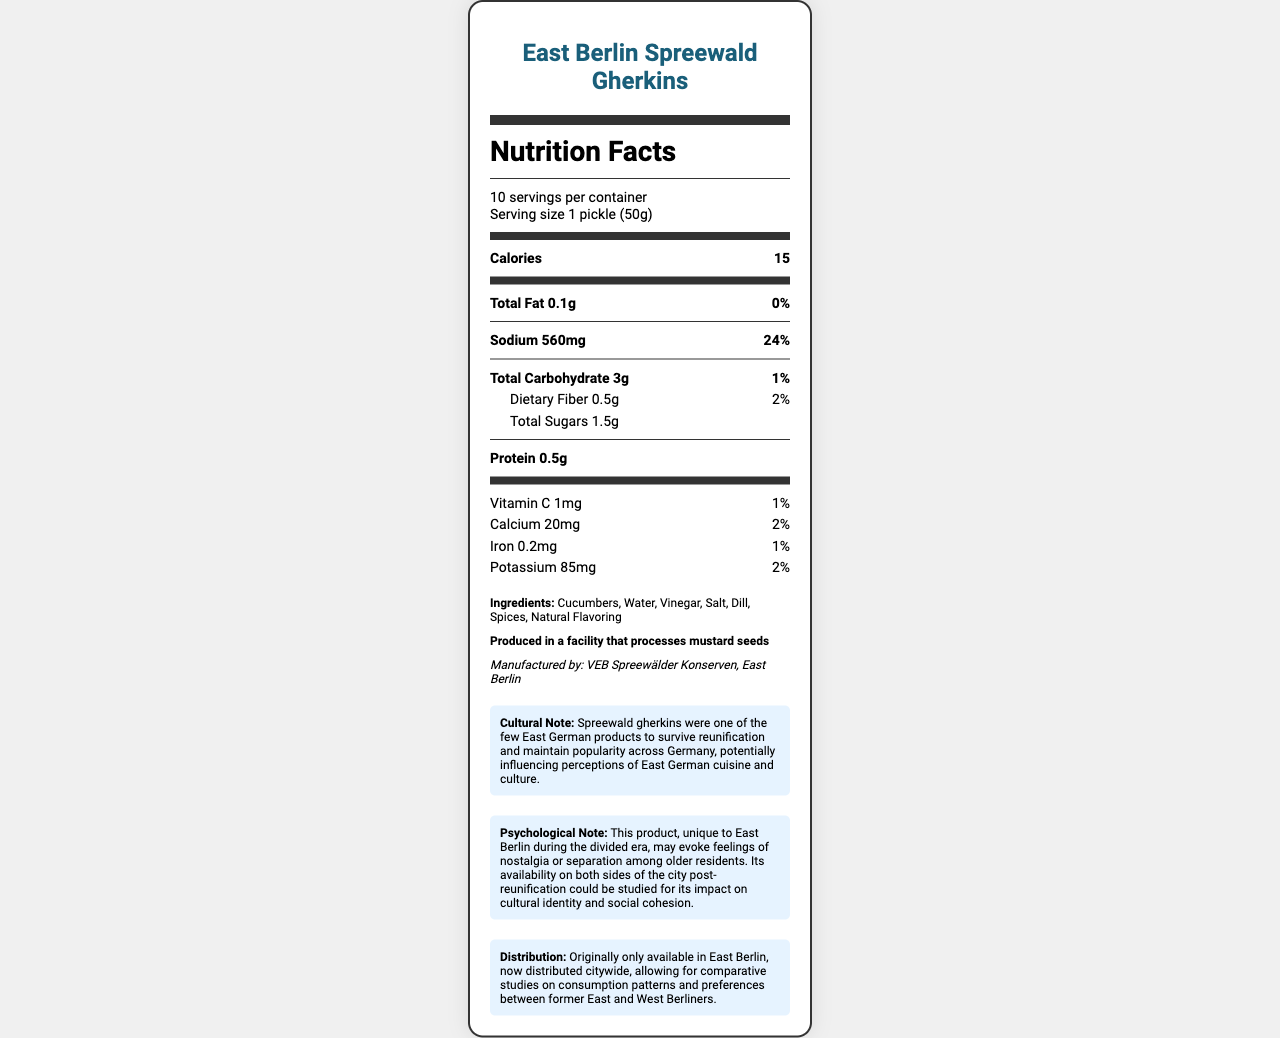what is the serving size for East Berlin Spreewald Gherkins? The document directly states that the serving size is 1 pickle (50g).
Answer: 1 pickle (50g) how much sodium is in one serving? The document lists the sodium content as 560mg per serving.
Answer: 560mg how many calories are there per serving? The document states that each serving contains 15 calories.
Answer: 15 what is the total fat content in one serving? The total fat content per serving is provided as 0.1g in the document.
Answer: 0.1g how much dietary fiber does one pickle contain? According to the nutrition facts, one pickle contains 0.5g of dietary fiber.
Answer: 0.5g how many servings are there per container? The document states there are 10 servings per container.
Answer: 10 who manufactures East Berlin Spreewald Gherkins? The manufacturer listed is VEB Spreewälder Konserven, East Berlin.
Answer: VEB Spreewälder Konserven, East Berlin are these gherkins a significant source of iron? The document shows that one serving provides only 1% of the daily value for iron, which is not significant.
Answer: No what are the ingredients of the product? The ingredients are listed as Cucumbers, Water, Vinegar, Salt, Dill, Spices, and Natural Flavoring.
Answer: Cucumbers, Water, Vinegar, Salt, Dill, Spices, Natural Flavoring which nutrient has the highest daily value percentage per serving? A. Sodium B. Total Fat C. Protein Sodium has the highest daily value percentage at 24%, as indicated in the document.
Answer: A which vitamin is present in this product? A. Vitamin C B. Vitamin D C. Vitamin E D. No vitamins listed The document lists Vitamin C as present in the product.
Answer: A is the product produced in a facility that processes mustard seeds? The allergen information states that it is produced in a facility that processes mustard seeds.
Answer: Yes explain the cultural significance of this product The document states that Spreewald gherkins maintained their popularity post-reunification and may influence perceptions of East German culture and cuisine.
Answer: Spreewald gherkins were one of the few East German products to survive reunification and maintain popularity across Germany, potentially influencing perceptions of East German cuisine and culture. does this product contain more potassium or calcium per serving? The document lists 85mg of potassium and 20mg of calcium per serving, indicating there is more potassium.
Answer: Potassium how might older residents of East Berlin feel about this product? The psychological note mentions that adults who lived during the divided era might feel nostalgic or sense of separation when seeing this product.
Answer: Nostalgic or separated how many grams of total sugars does the product have per serving? The document lists the total sugars per serving as 1.5g.
Answer: 1.5g does this product have vitamin D? The document only lists Vitamin C and does not provide information about other vitamins such as Vitamin D.
Answer: Cannot be determined what is the main idea of the document? The document extensively details nutritional facts, ingredients, manufacturer, cultural and psychological notes, and distribution changes of the East Berlin Spreewald Gherkins.
Answer: The document provides detailed nutritional information and cultural context for East Berlin Spreewald Gherkins, a product from East Germany, highlighting its ingredients, manufacturer, and its psychological and cultural significance post-reunification. 